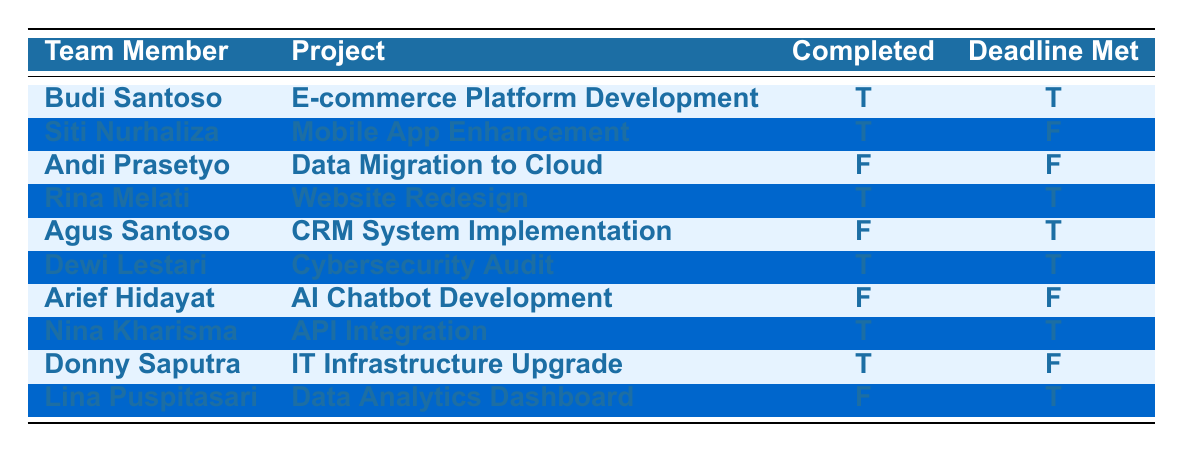What are the names of team members who completed their projects? The completed projects are by Budi Santoso, Rina Melati, Dewi Lestari, and Nina Kharisma. These are the team members with a "Completed" value of true in the table.
Answer: Budi Santoso, Rina Melati, Dewi Lestari, Nina Kharisma How many team members met their deadlines? The team members who met their deadlines are Budi Santoso, Rina Melati, Dewi Lestari, and Nina Kharisma. So there are four members with "Deadline Met" as true.
Answer: 4 Is there any team member who completed their project but did not meet the deadline? Donny Saputra completed his project, but the deadline was not met. This is determined by looking for "Completed" as true and "Deadline Met" as false in the table.
Answer: Yes Which project was completed by Agus Santoso? The project completed by Agus Santoso is "CRM System Implementation". This is directly referenced by matching the team member's name to the associated project.
Answer: CRM System Implementation How many projects were completed on time (deadline met)? The total number of projects that were completed on time is four, which includes projects by Budi Santoso, Rina Melati, Dewi Lestari, and Nina Kharisma. A tally of those with "Completed" and "Deadline Met" as true provides this count.
Answer: 4 Which team member failed to complete their project and did not meet the deadline? Andi Prasetyo and Arief Hidayat are the team members who failed to complete their projects and also did not meet their deadlines. This is found by identifying rows with both "Completed" and "Deadline Met" as false.
Answer: Andi Prasetyo, Arief Hidayat What is the number of projects that were not completed? There are five projects that were not completed. By counting the rows where "Completed" is false, we can confirm this total.
Answer: 5 Can you list all team members who met their deadlines regardless of completion? The team members who met their deadlines are Budi Santoso, Agus Santoso, Rina Melati, Dewi Lestari, and Lina Puspitasari. This is gathered by identifying all members with "Deadline Met" marked true.
Answer: Budi Santoso, Agus Santoso, Rina Melati, Dewi Lestari, Lina Puspitasari 